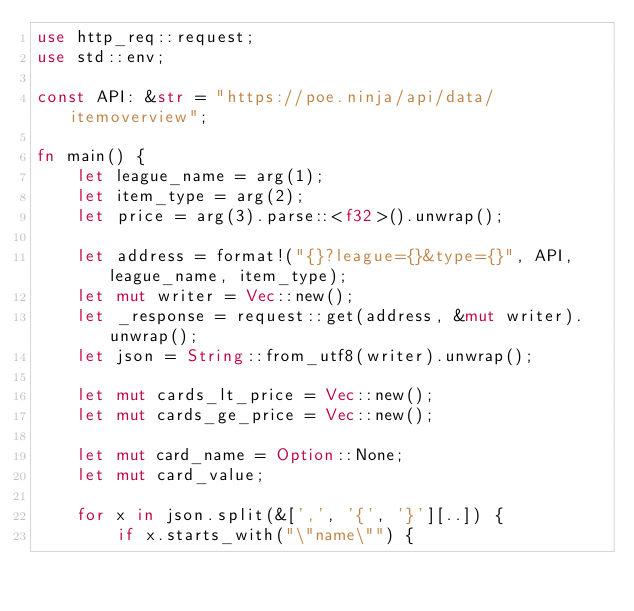Convert code to text. <code><loc_0><loc_0><loc_500><loc_500><_Rust_>use http_req::request;
use std::env;

const API: &str = "https://poe.ninja/api/data/itemoverview";

fn main() {
    let league_name = arg(1);
    let item_type = arg(2);
    let price = arg(3).parse::<f32>().unwrap();

    let address = format!("{}?league={}&type={}", API, league_name, item_type);
    let mut writer = Vec::new();
    let _response = request::get(address, &mut writer).unwrap();
    let json = String::from_utf8(writer).unwrap();

    let mut cards_lt_price = Vec::new();
    let mut cards_ge_price = Vec::new();

    let mut card_name = Option::None;
    let mut card_value;

    for x in json.split(&[',', '{', '}'][..]) {
        if x.starts_with("\"name\"") {</code> 